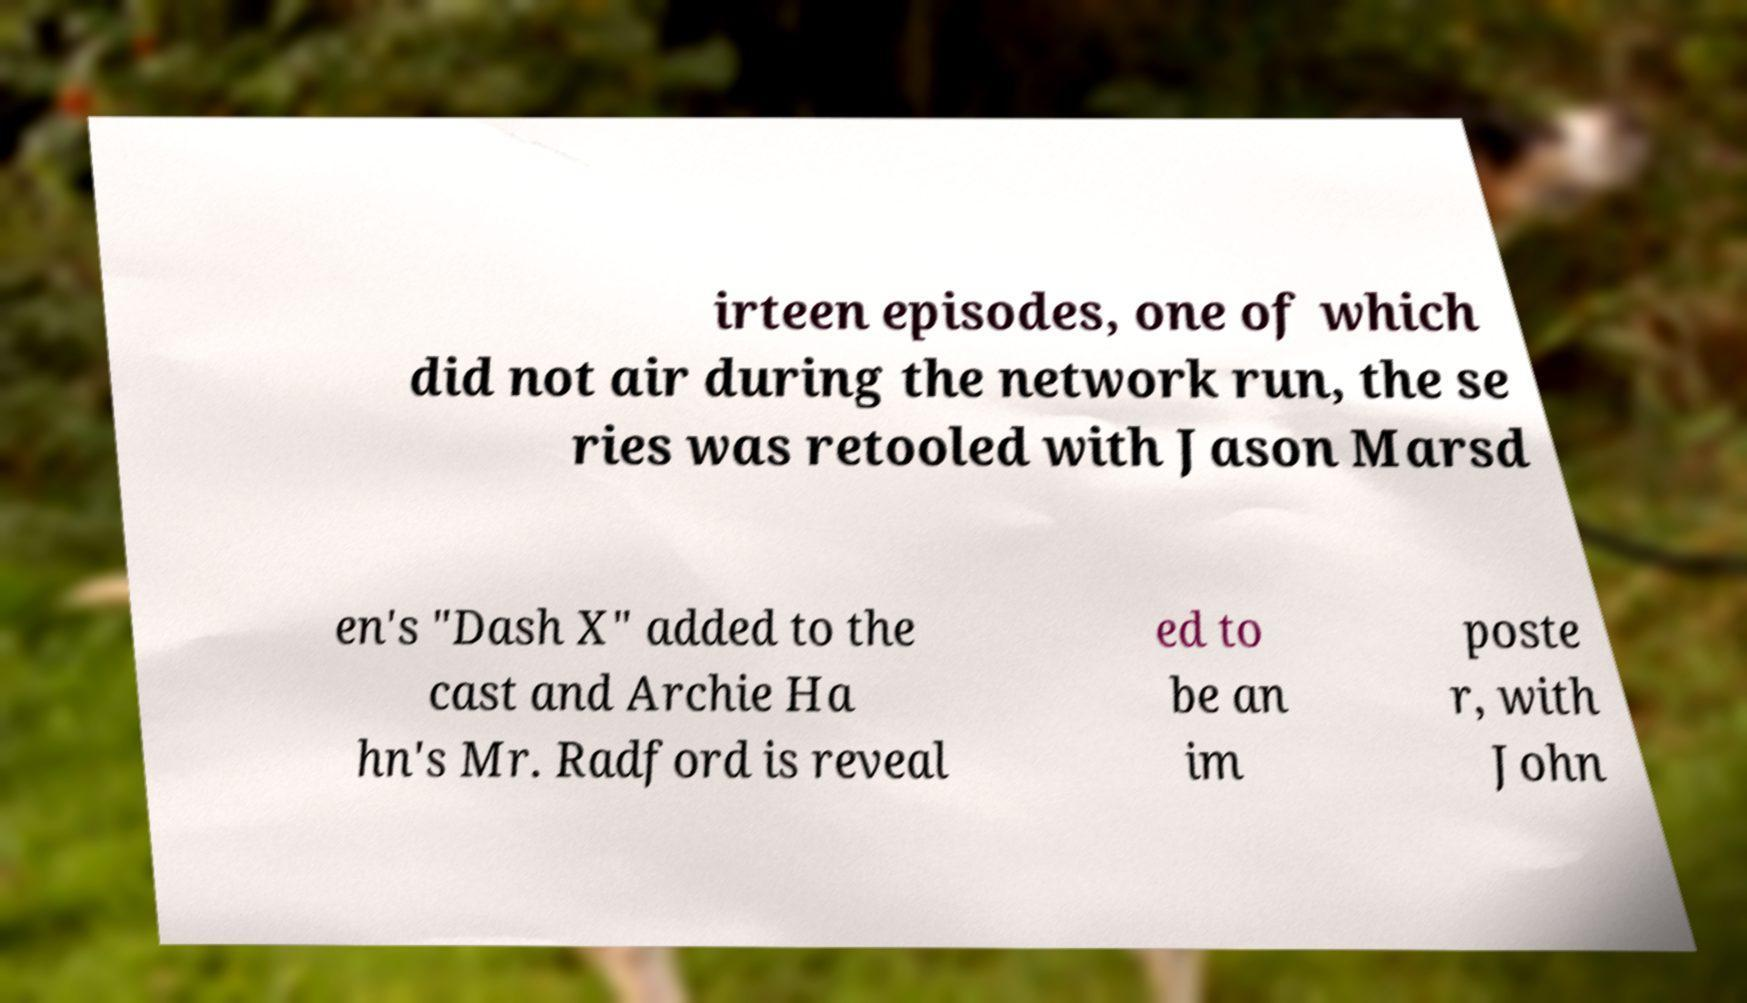Can you read and provide the text displayed in the image?This photo seems to have some interesting text. Can you extract and type it out for me? irteen episodes, one of which did not air during the network run, the se ries was retooled with Jason Marsd en's "Dash X" added to the cast and Archie Ha hn's Mr. Radford is reveal ed to be an im poste r, with John 